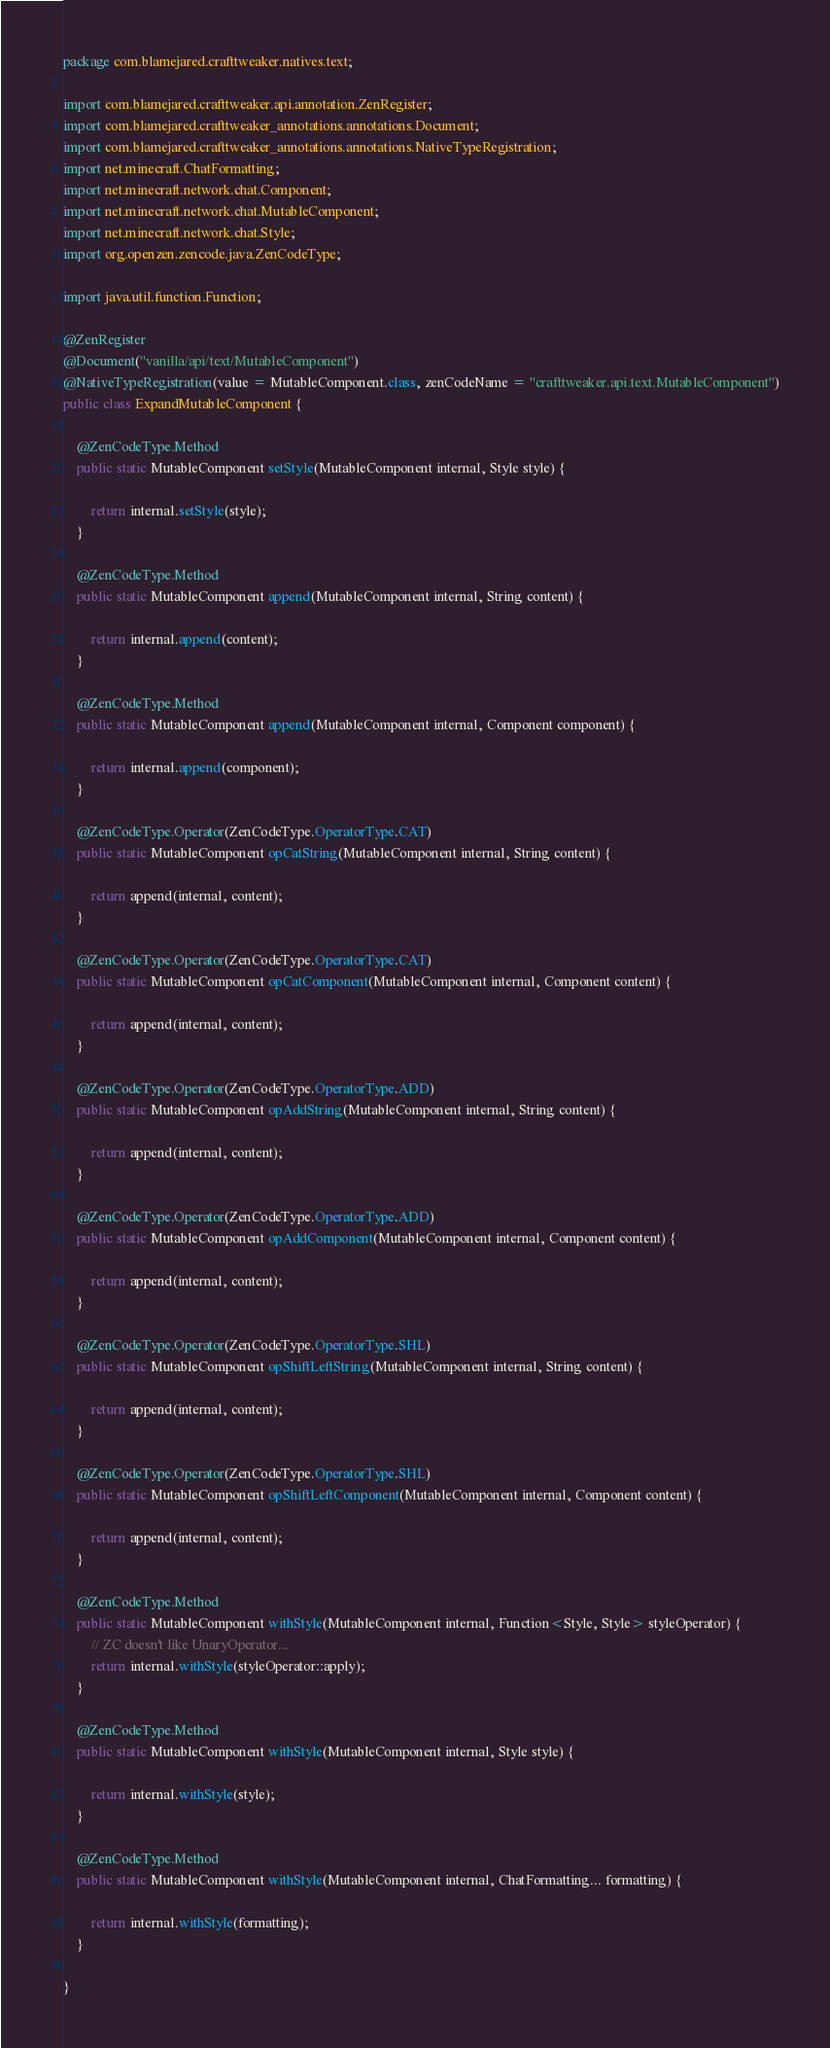Convert code to text. <code><loc_0><loc_0><loc_500><loc_500><_Java_>package com.blamejared.crafttweaker.natives.text;

import com.blamejared.crafttweaker.api.annotation.ZenRegister;
import com.blamejared.crafttweaker_annotations.annotations.Document;
import com.blamejared.crafttweaker_annotations.annotations.NativeTypeRegistration;
import net.minecraft.ChatFormatting;
import net.minecraft.network.chat.Component;
import net.minecraft.network.chat.MutableComponent;
import net.minecraft.network.chat.Style;
import org.openzen.zencode.java.ZenCodeType;

import java.util.function.Function;

@ZenRegister
@Document("vanilla/api/text/MutableComponent")
@NativeTypeRegistration(value = MutableComponent.class, zenCodeName = "crafttweaker.api.text.MutableComponent")
public class ExpandMutableComponent {
    
    @ZenCodeType.Method
    public static MutableComponent setStyle(MutableComponent internal, Style style) {
        
        return internal.setStyle(style);
    }
    
    @ZenCodeType.Method
    public static MutableComponent append(MutableComponent internal, String content) {
        
        return internal.append(content);
    }
    
    @ZenCodeType.Method
    public static MutableComponent append(MutableComponent internal, Component component) {
        
        return internal.append(component);
    }
    
    @ZenCodeType.Operator(ZenCodeType.OperatorType.CAT)
    public static MutableComponent opCatString(MutableComponent internal, String content) {
        
        return append(internal, content);
    }
    
    @ZenCodeType.Operator(ZenCodeType.OperatorType.CAT)
    public static MutableComponent opCatComponent(MutableComponent internal, Component content) {
        
        return append(internal, content);
    }
    
    @ZenCodeType.Operator(ZenCodeType.OperatorType.ADD)
    public static MutableComponent opAddString(MutableComponent internal, String content) {
        
        return append(internal, content);
    }
    
    @ZenCodeType.Operator(ZenCodeType.OperatorType.ADD)
    public static MutableComponent opAddComponent(MutableComponent internal, Component content) {
        
        return append(internal, content);
    }
    
    @ZenCodeType.Operator(ZenCodeType.OperatorType.SHL)
    public static MutableComponent opShiftLeftString(MutableComponent internal, String content) {
        
        return append(internal, content);
    }
    
    @ZenCodeType.Operator(ZenCodeType.OperatorType.SHL)
    public static MutableComponent opShiftLeftComponent(MutableComponent internal, Component content) {
        
        return append(internal, content);
    }
    
    @ZenCodeType.Method
    public static MutableComponent withStyle(MutableComponent internal, Function<Style, Style> styleOperator) {
        // ZC doesn't like UnaryOperator...
        return internal.withStyle(styleOperator::apply);
    }
    
    @ZenCodeType.Method
    public static MutableComponent withStyle(MutableComponent internal, Style style) {
        
        return internal.withStyle(style);
    }
    
    @ZenCodeType.Method
    public static MutableComponent withStyle(MutableComponent internal, ChatFormatting... formatting) {
        
        return internal.withStyle(formatting);
    }
    
}
</code> 